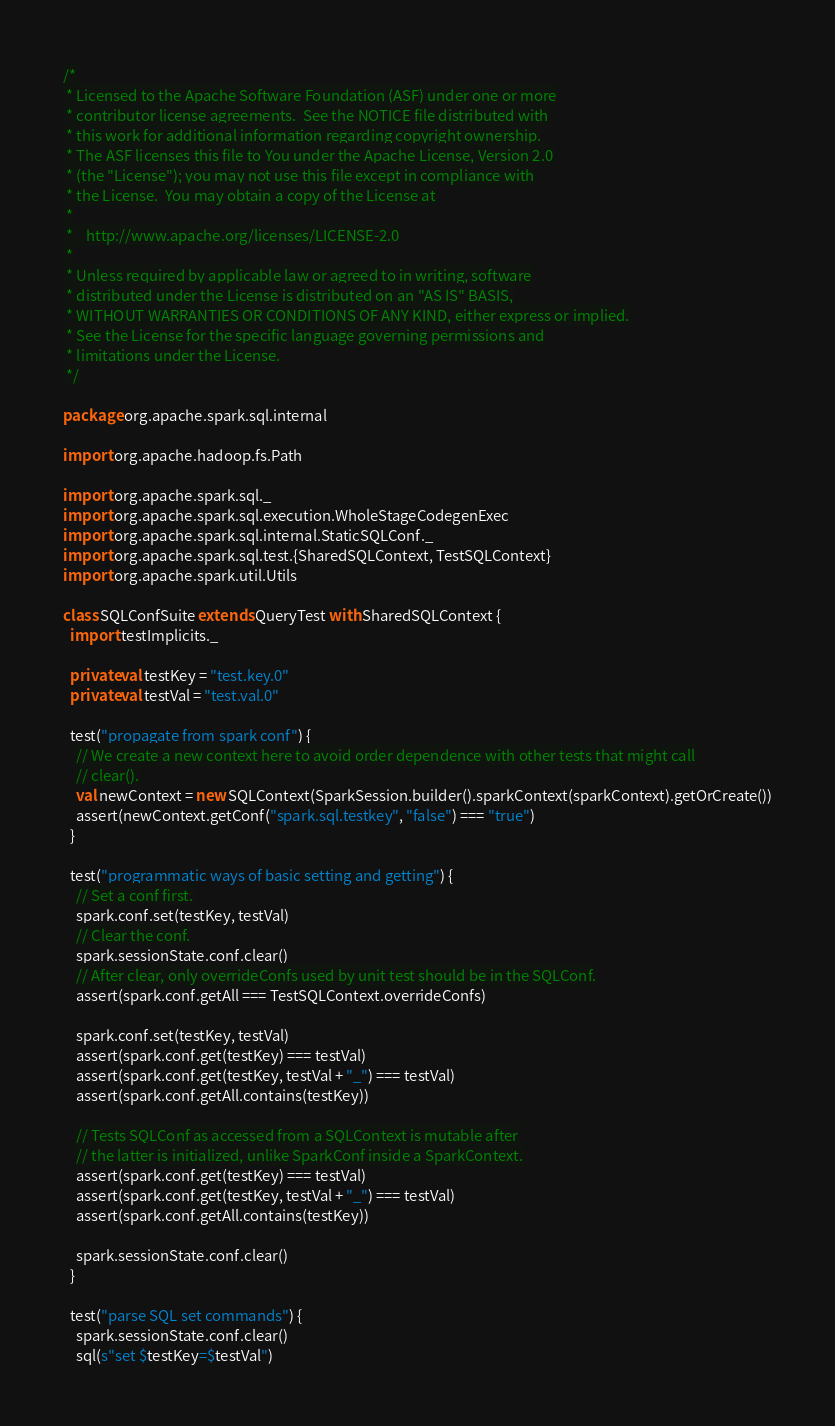Convert code to text. <code><loc_0><loc_0><loc_500><loc_500><_Scala_>/*
 * Licensed to the Apache Software Foundation (ASF) under one or more
 * contributor license agreements.  See the NOTICE file distributed with
 * this work for additional information regarding copyright ownership.
 * The ASF licenses this file to You under the Apache License, Version 2.0
 * (the "License"); you may not use this file except in compliance with
 * the License.  You may obtain a copy of the License at
 *
 *    http://www.apache.org/licenses/LICENSE-2.0
 *
 * Unless required by applicable law or agreed to in writing, software
 * distributed under the License is distributed on an "AS IS" BASIS,
 * WITHOUT WARRANTIES OR CONDITIONS OF ANY KIND, either express or implied.
 * See the License for the specific language governing permissions and
 * limitations under the License.
 */

package org.apache.spark.sql.internal

import org.apache.hadoop.fs.Path

import org.apache.spark.sql._
import org.apache.spark.sql.execution.WholeStageCodegenExec
import org.apache.spark.sql.internal.StaticSQLConf._
import org.apache.spark.sql.test.{SharedSQLContext, TestSQLContext}
import org.apache.spark.util.Utils

class SQLConfSuite extends QueryTest with SharedSQLContext {
  import testImplicits._

  private val testKey = "test.key.0"
  private val testVal = "test.val.0"

  test("propagate from spark conf") {
    // We create a new context here to avoid order dependence with other tests that might call
    // clear().
    val newContext = new SQLContext(SparkSession.builder().sparkContext(sparkContext).getOrCreate())
    assert(newContext.getConf("spark.sql.testkey", "false") === "true")
  }

  test("programmatic ways of basic setting and getting") {
    // Set a conf first.
    spark.conf.set(testKey, testVal)
    // Clear the conf.
    spark.sessionState.conf.clear()
    // After clear, only overrideConfs used by unit test should be in the SQLConf.
    assert(spark.conf.getAll === TestSQLContext.overrideConfs)

    spark.conf.set(testKey, testVal)
    assert(spark.conf.get(testKey) === testVal)
    assert(spark.conf.get(testKey, testVal + "_") === testVal)
    assert(spark.conf.getAll.contains(testKey))

    // Tests SQLConf as accessed from a SQLContext is mutable after
    // the latter is initialized, unlike SparkConf inside a SparkContext.
    assert(spark.conf.get(testKey) === testVal)
    assert(spark.conf.get(testKey, testVal + "_") === testVal)
    assert(spark.conf.getAll.contains(testKey))

    spark.sessionState.conf.clear()
  }

  test("parse SQL set commands") {
    spark.sessionState.conf.clear()
    sql(s"set $testKey=$testVal")</code> 